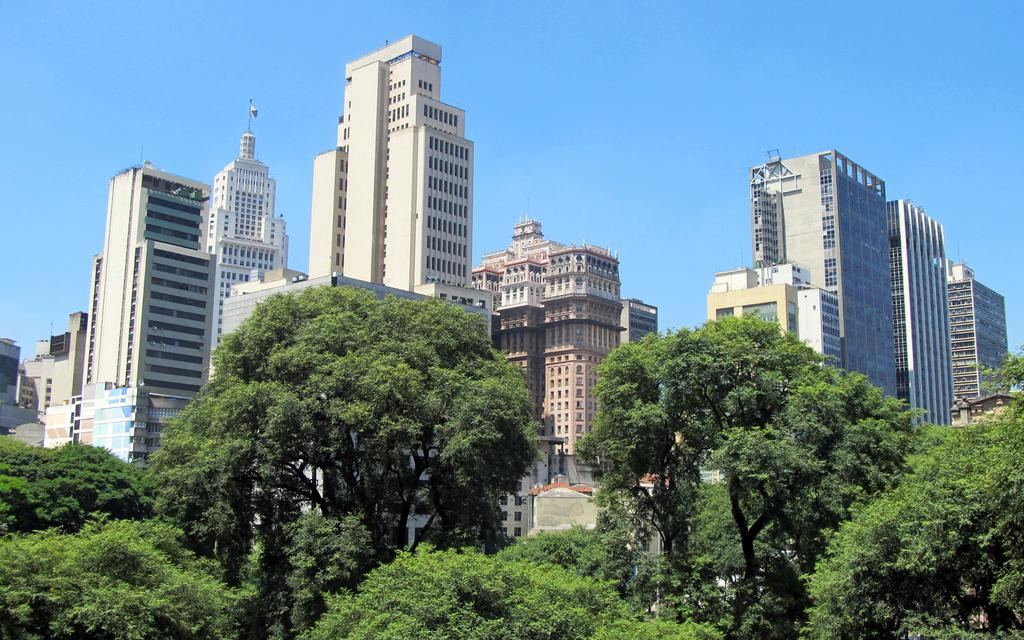What type of vegetation can be seen in the image? There are trees in the image. What is the color of the trees? The trees are green. What can be seen in the background of the image? There are buildings in the background of the image. What colors are the buildings? The buildings are in white, cream, and brown colors. What is the color of the sky in the image? The sky is blue. Where is the pail located in the image? There is no pail present in the image. What type of shelf can be seen in the image? There is no shelf present in the image. 